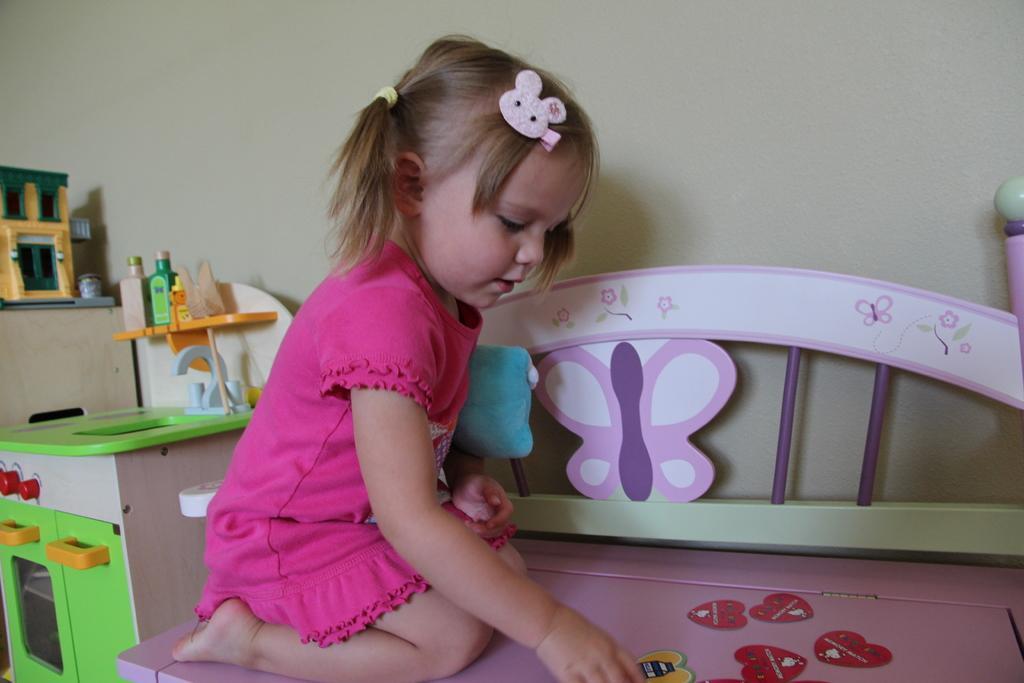Can you describe this image briefly? In this image I can see a baby sitting wearing pink color dress, at left I can see few objects on the table and the table is in green color, at the background the wall is in cream color. 